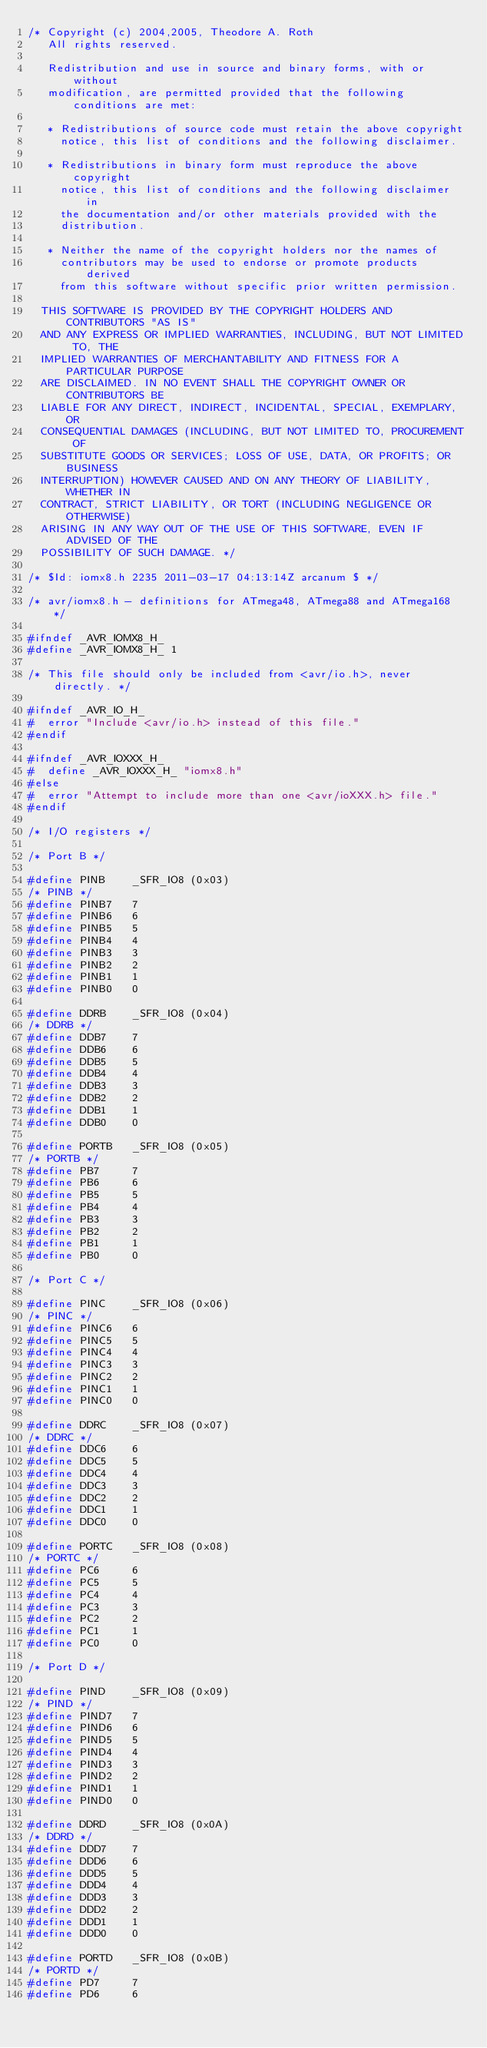<code> <loc_0><loc_0><loc_500><loc_500><_C_>/* Copyright (c) 2004,2005, Theodore A. Roth
   All rights reserved.

   Redistribution and use in source and binary forms, with or without
   modification, are permitted provided that the following conditions are met:

   * Redistributions of source code must retain the above copyright
     notice, this list of conditions and the following disclaimer.

   * Redistributions in binary form must reproduce the above copyright
     notice, this list of conditions and the following disclaimer in
     the documentation and/or other materials provided with the
     distribution.

   * Neither the name of the copyright holders nor the names of
     contributors may be used to endorse or promote products derived
     from this software without specific prior written permission.

  THIS SOFTWARE IS PROVIDED BY THE COPYRIGHT HOLDERS AND CONTRIBUTORS "AS IS"
  AND ANY EXPRESS OR IMPLIED WARRANTIES, INCLUDING, BUT NOT LIMITED TO, THE
  IMPLIED WARRANTIES OF MERCHANTABILITY AND FITNESS FOR A PARTICULAR PURPOSE
  ARE DISCLAIMED. IN NO EVENT SHALL THE COPYRIGHT OWNER OR CONTRIBUTORS BE
  LIABLE FOR ANY DIRECT, INDIRECT, INCIDENTAL, SPECIAL, EXEMPLARY, OR
  CONSEQUENTIAL DAMAGES (INCLUDING, BUT NOT LIMITED TO, PROCUREMENT OF
  SUBSTITUTE GOODS OR SERVICES; LOSS OF USE, DATA, OR PROFITS; OR BUSINESS
  INTERRUPTION) HOWEVER CAUSED AND ON ANY THEORY OF LIABILITY, WHETHER IN
  CONTRACT, STRICT LIABILITY, OR TORT (INCLUDING NEGLIGENCE OR OTHERWISE)
  ARISING IN ANY WAY OUT OF THE USE OF THIS SOFTWARE, EVEN IF ADVISED OF THE
  POSSIBILITY OF SUCH DAMAGE. */

/* $Id: iomx8.h 2235 2011-03-17 04:13:14Z arcanum $ */

/* avr/iomx8.h - definitions for ATmega48, ATmega88 and ATmega168 */

#ifndef _AVR_IOMX8_H_
#define _AVR_IOMX8_H_ 1

/* This file should only be included from <avr/io.h>, never directly. */

#ifndef _AVR_IO_H_
#  error "Include <avr/io.h> instead of this file."
#endif

#ifndef _AVR_IOXXX_H_
#  define _AVR_IOXXX_H_ "iomx8.h"
#else
#  error "Attempt to include more than one <avr/ioXXX.h> file."
#endif 

/* I/O registers */

/* Port B */

#define PINB    _SFR_IO8 (0x03)
/* PINB */
#define PINB7   7
#define PINB6   6
#define PINB5   5
#define PINB4   4
#define PINB3   3
#define PINB2   2
#define PINB1   1
#define PINB0   0

#define DDRB    _SFR_IO8 (0x04)
/* DDRB */
#define DDB7    7
#define DDB6    6
#define DDB5    5
#define DDB4    4
#define DDB3    3
#define DDB2    2
#define DDB1    1
#define DDB0    0

#define PORTB   _SFR_IO8 (0x05)
/* PORTB */
#define PB7     7
#define PB6     6
#define PB5     5
#define PB4     4
#define PB3     3
#define PB2     2
#define PB1     1
#define PB0     0

/* Port C */

#define PINC    _SFR_IO8 (0x06)
/* PINC */
#define PINC6   6
#define PINC5   5
#define PINC4   4
#define PINC3   3
#define PINC2   2
#define PINC1   1
#define PINC0   0

#define DDRC    _SFR_IO8 (0x07)
/* DDRC */
#define DDC6    6
#define DDC5    5
#define DDC4    4
#define DDC3    3
#define DDC2    2
#define DDC1    1
#define DDC0    0

#define PORTC   _SFR_IO8 (0x08)
/* PORTC */
#define PC6     6
#define PC5     5
#define PC4     4
#define PC3     3
#define PC2     2
#define PC1     1
#define PC0     0

/* Port D */

#define PIND    _SFR_IO8 (0x09)
/* PIND */
#define PIND7   7
#define PIND6   6
#define PIND5   5
#define PIND4   4
#define PIND3   3
#define PIND2   2
#define PIND1   1
#define PIND0   0

#define DDRD    _SFR_IO8 (0x0A)
/* DDRD */
#define DDD7    7
#define DDD6    6
#define DDD5    5
#define DDD4    4
#define DDD3    3
#define DDD2    2
#define DDD1    1
#define DDD0    0

#define PORTD   _SFR_IO8 (0x0B)
/* PORTD */
#define PD7     7
#define PD6     6</code> 